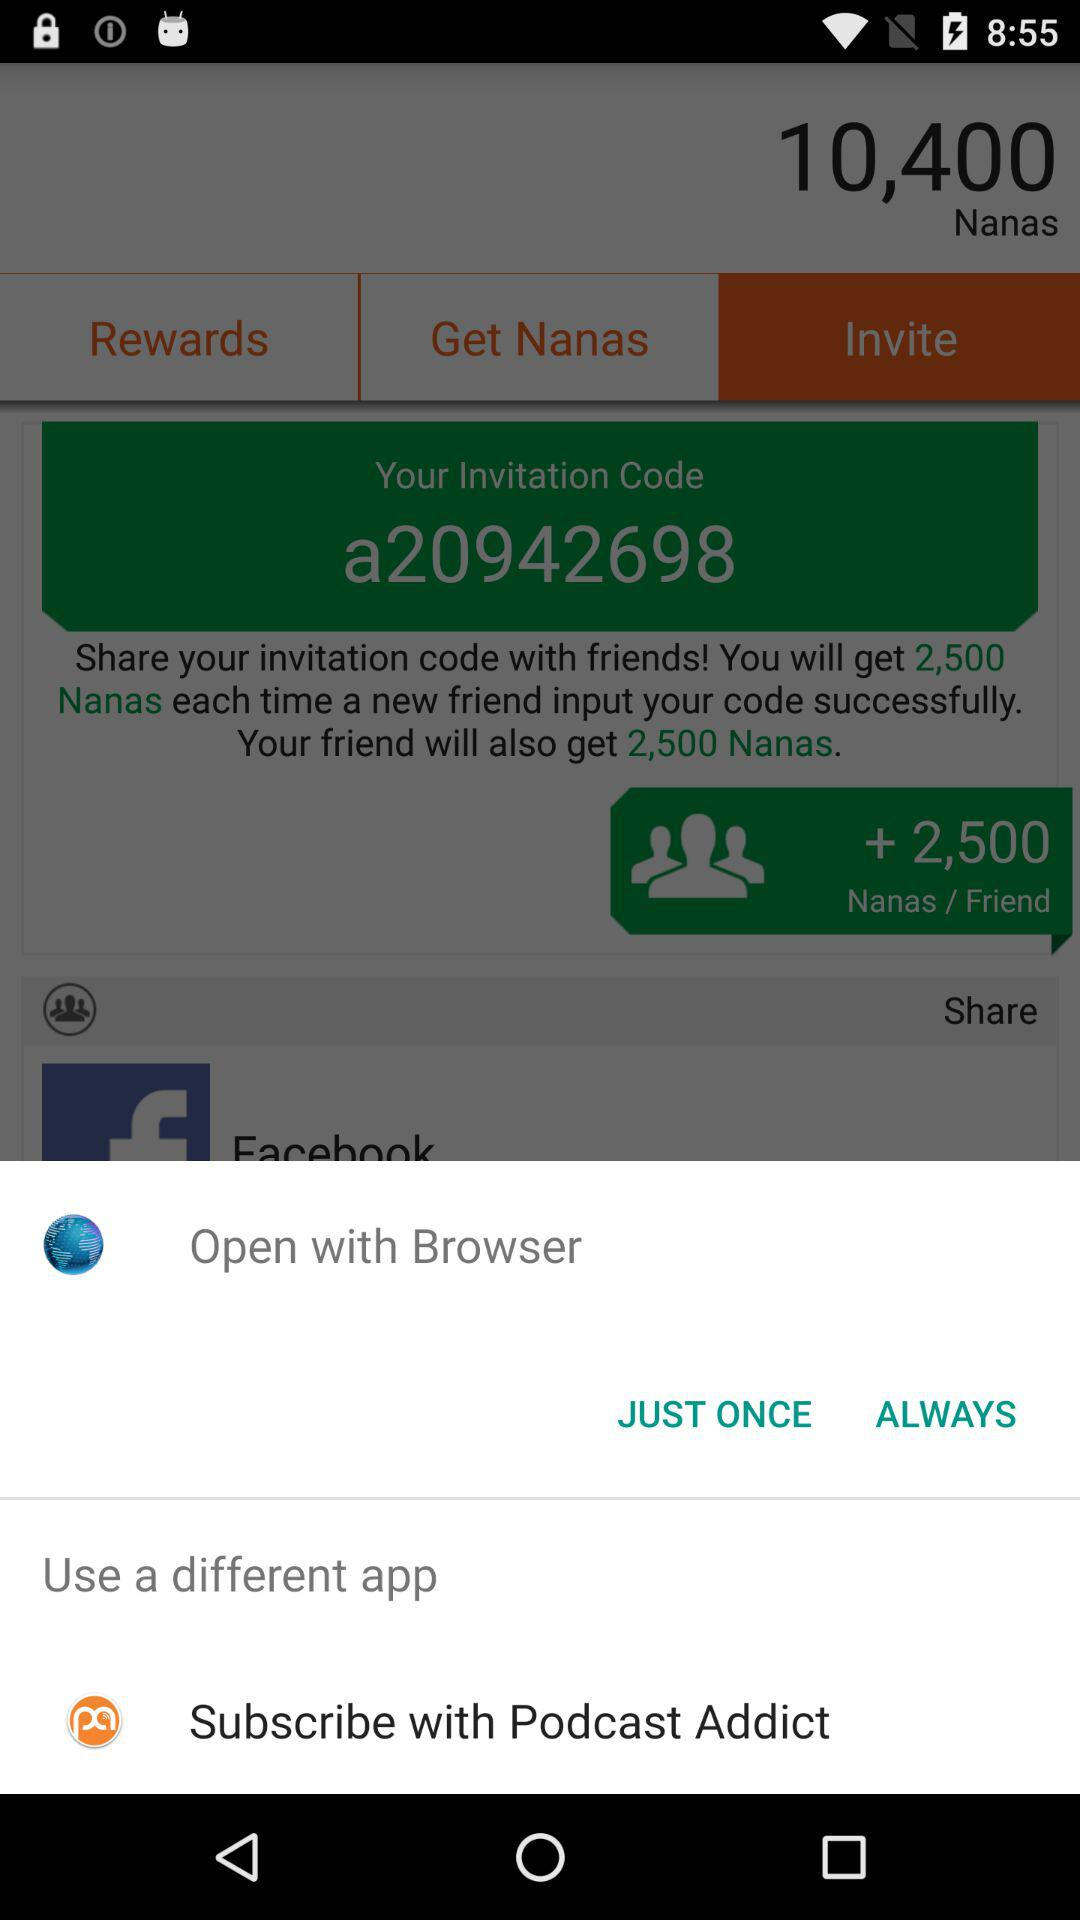What is the invitation code? The invitation code is a20942698. 